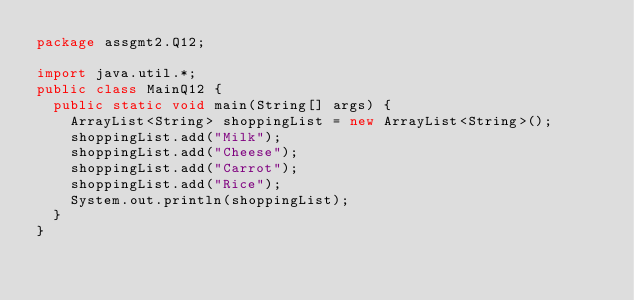Convert code to text. <code><loc_0><loc_0><loc_500><loc_500><_Java_>package assgmt2.Q12;

import java.util.*;
public class MainQ12 {
  public static void main(String[] args) {
    ArrayList<String> shoppingList = new ArrayList<String>();
    shoppingList.add("Milk");
    shoppingList.add("Cheese");
    shoppingList.add("Carrot");
    shoppingList.add("Rice");
    System.out.println(shoppingList);
  }
}
</code> 